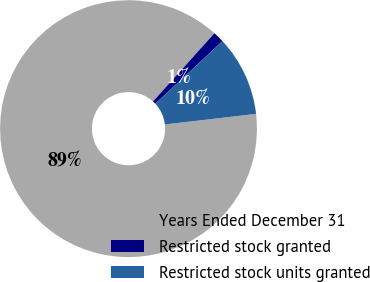<chart> <loc_0><loc_0><loc_500><loc_500><pie_chart><fcel>Years Ended December 31<fcel>Restricted stock granted<fcel>Restricted stock units granted<nl><fcel>88.5%<fcel>1.39%<fcel>10.1%<nl></chart> 